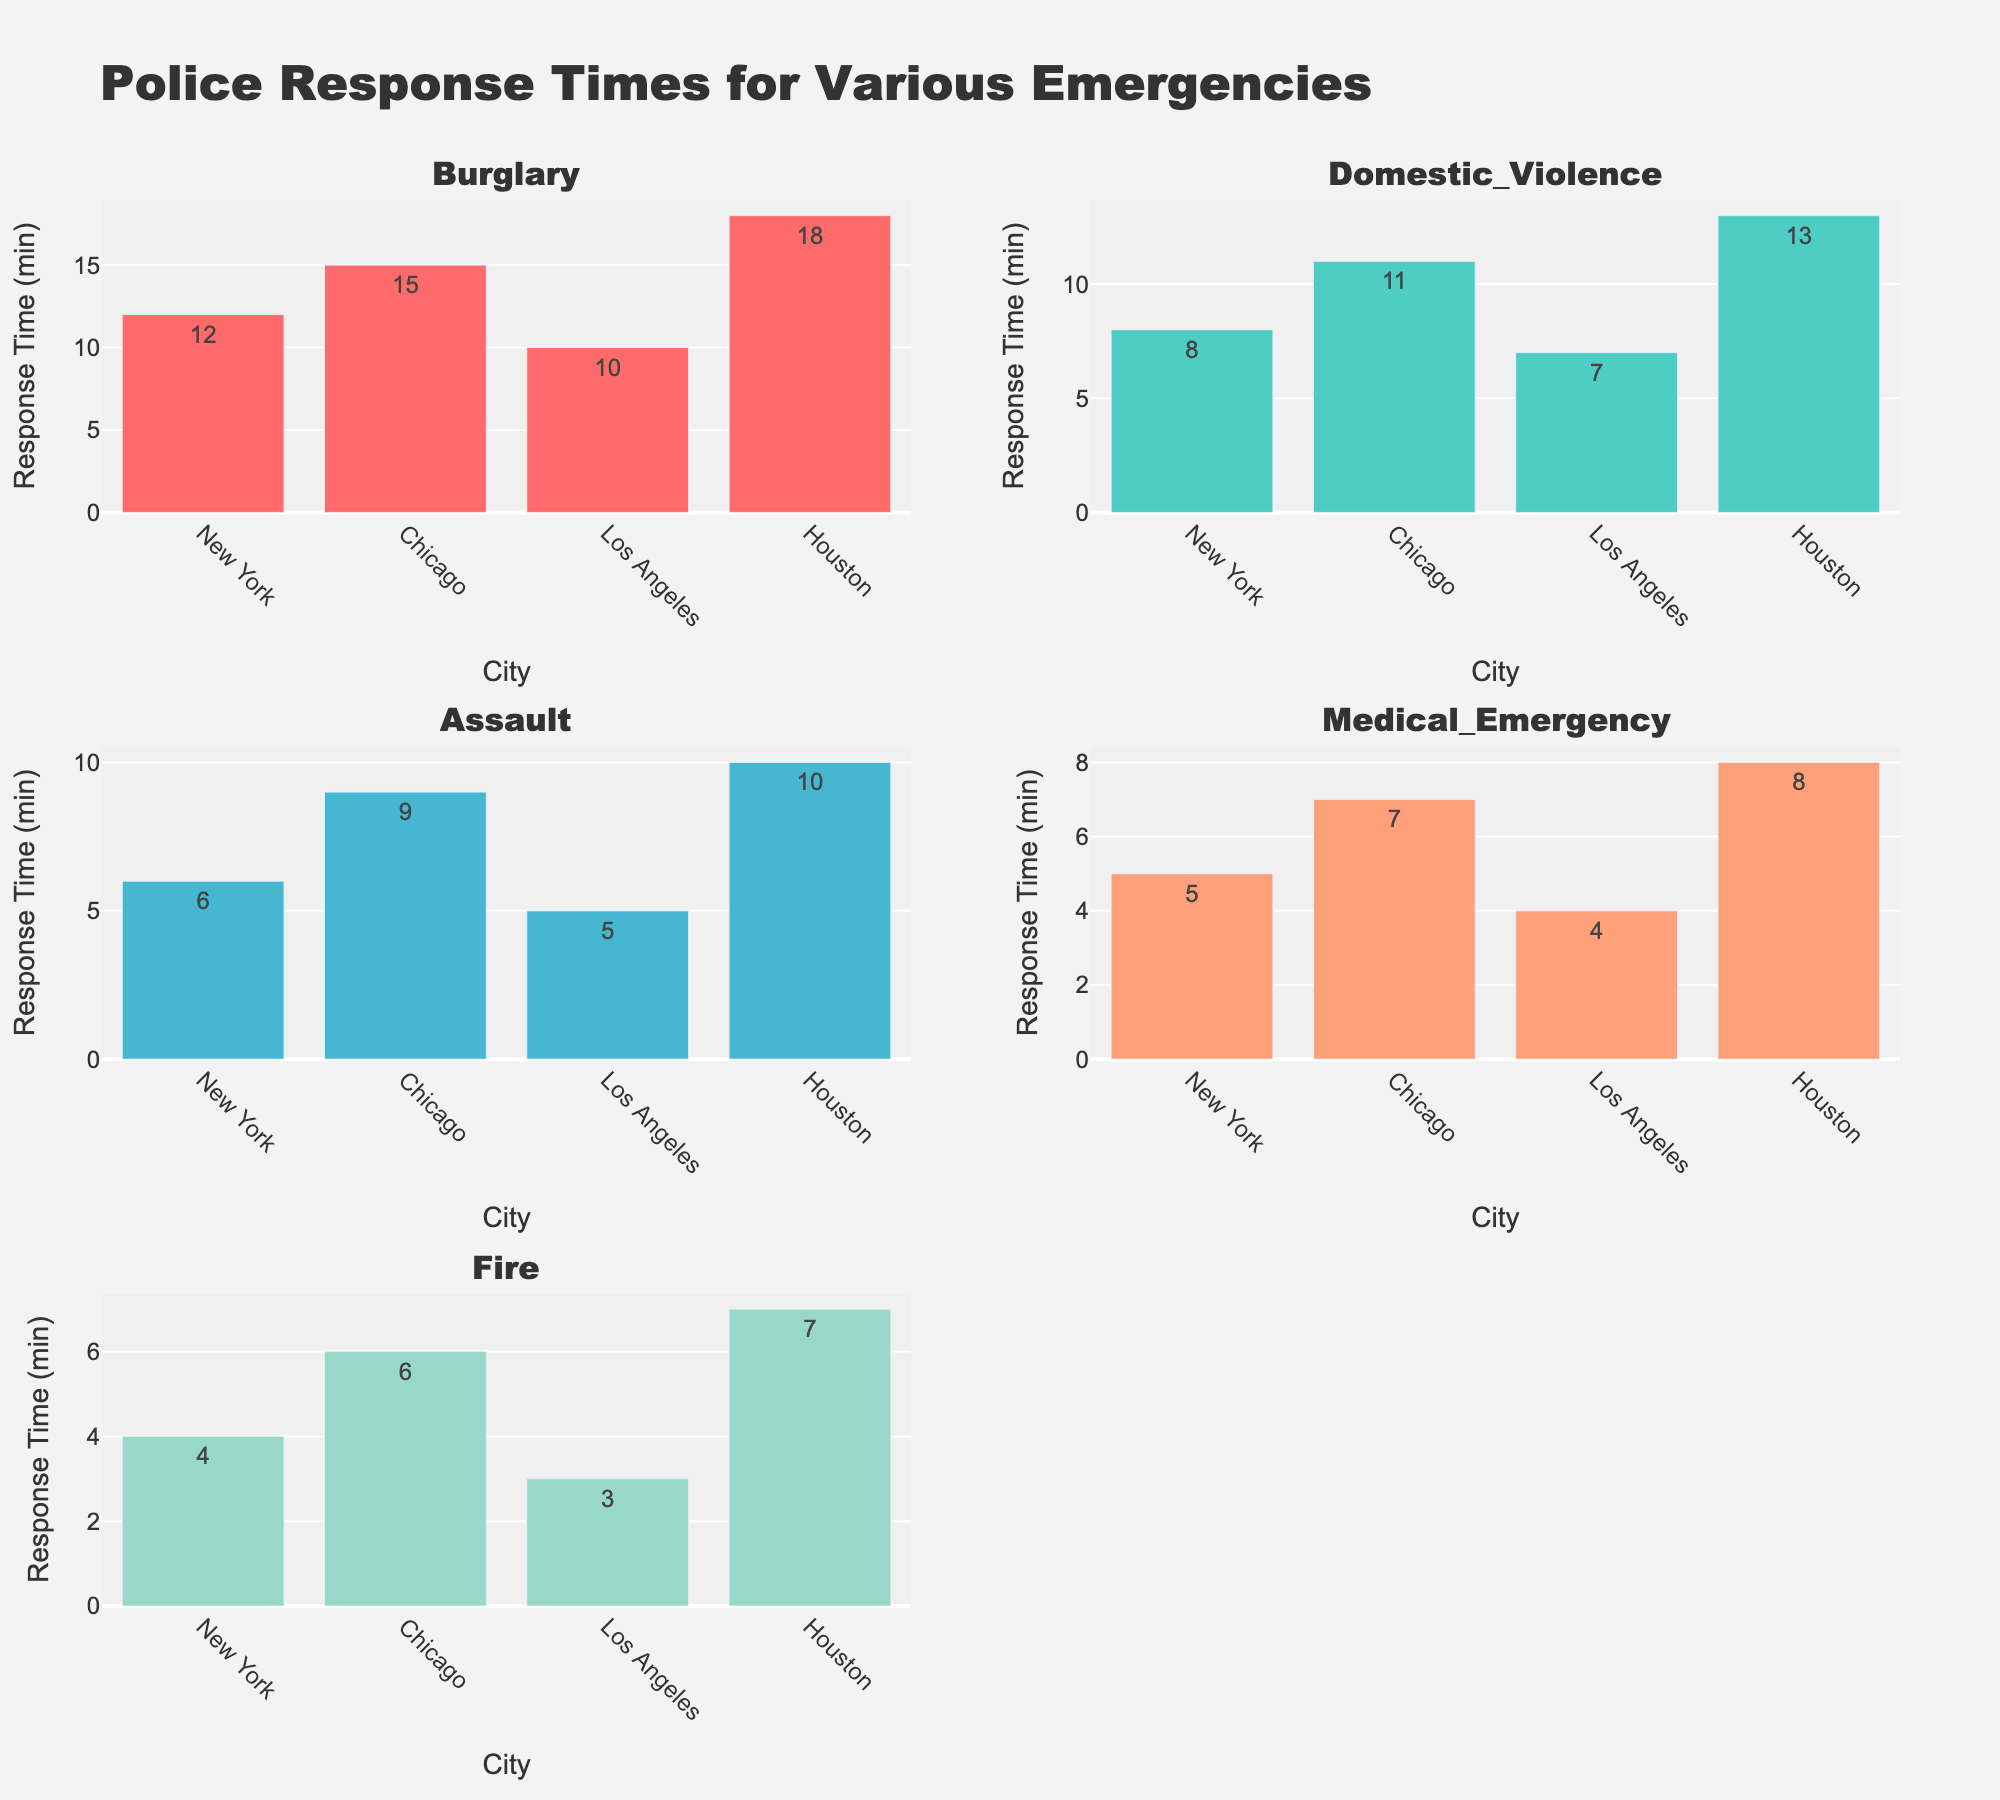What is the title of the plotted figure? The title can be found at the top center of the figure. It reads "Alabama State Hornets Offensive Performance (2013-2022)" which indicates the chart's focus on offensive performance metrics over the specified period.
Answer: Alabama State Hornets Offensive Performance (2013-2022) Which position had the highest number of touchdowns in 2016? Look at the Touchdowns subplot and find the data point for each position in the year 2016. The Quarterback had 35 touchdowns, Running Back had 20, and Wide Receiver had 16.
Answer: Quarterback How did the running back's rushing yards change from 2019 to 2020? Examine the Rushing_Yards subplot, locate the data points for the Running Back for the years 2019 and 2020. In 2019, the Running Back had 1450 rushing yards, and in 2020, it had 1100 rushing yards. The change is calculated as 1450 - 1100.
Answer: Decreased by 350 yards Which season did the wide receiver have the highest receiving yards, and how many yards was it? Look at the Receiving_Yards subplot, identify the peak value for Wide Receiver across all seasons. The highest point is in 2021 with 1400 receiving yards.
Answer: 2021, 1400 yards Compare the rushing yards of running backs and receiving yards of wide receivers in the year 2014. Which position had more yards and by how much? Refer to both the Rushing_Yards and Receiving_Yards subplots. For 2014, Running Backs had 1350 rushing yards and Wide Receivers had 1200 receiving yards. The difference is 1350 - 1200.
Answer: Running Backs, 150 yards Between which two consecutive seasons did the Quarterback's passing yards see the largest increase? Inspect the Passing_Yards subplot, noting the transitions between each pair of consecutive seasons. Compare the differences and identify the largest one. The biggest increase is between 2016 (3200 yards) and 2017 (2800 yards), an increase of 400 yards.
Answer: 2016 and 2017 In which season did all three positions (Quarterback, Running Back, and Wide Receiver) have a decrease in their respective performance metrics (passing, rushing, and receiving yards) compared to the previous season? Review each subplot (Passing, Rushing, Receiving Yards) for all positions. Identify if all three positions have lower values in any specific season than they had in the preceding season. In 2017, all positions show decreases from their 2016 values.
Answer: 2017 What is the average number of touchdowns scored by the Wide Receiver over the entire period? Calculate the average touchdowns for the Wide Receiver by summing up the touchdowns across all seasons and dividing by the number of seasons (10). The sums are 12, 14, 11, 16, 13, 15, 18, 10, 19, 14, totaling 142. The average is 142/10.
Answer: 14.2 Which position shows the most consistent performance in the Touchdowns metric over the years? Evaluate the Touchdowns subplot and assess the variability in the data points for each position. Consistency can be seen by observing the flatter trends or less fluctuation. The Quarterback shows the most consistent performance with relatively less fluctuation year over year.
Answer: Quarterback 